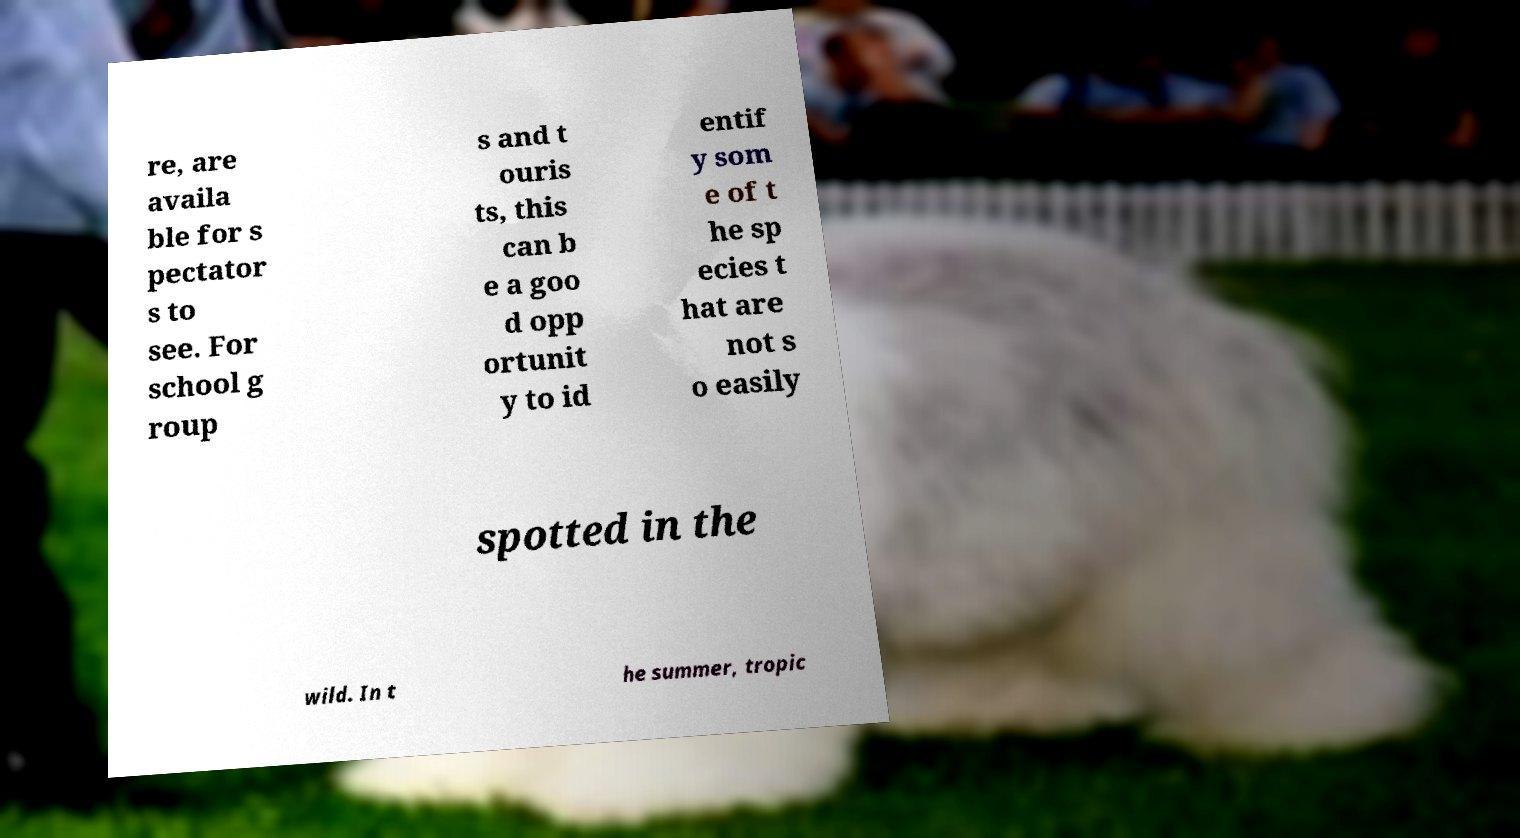Can you accurately transcribe the text from the provided image for me? re, are availa ble for s pectator s to see. For school g roup s and t ouris ts, this can b e a goo d opp ortunit y to id entif y som e of t he sp ecies t hat are not s o easily spotted in the wild. In t he summer, tropic 